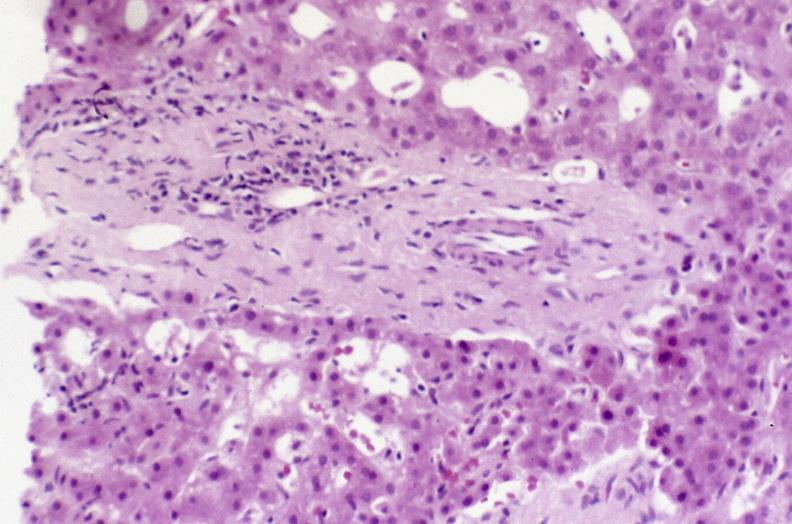s hepatobiliary present?
Answer the question using a single word or phrase. Yes 